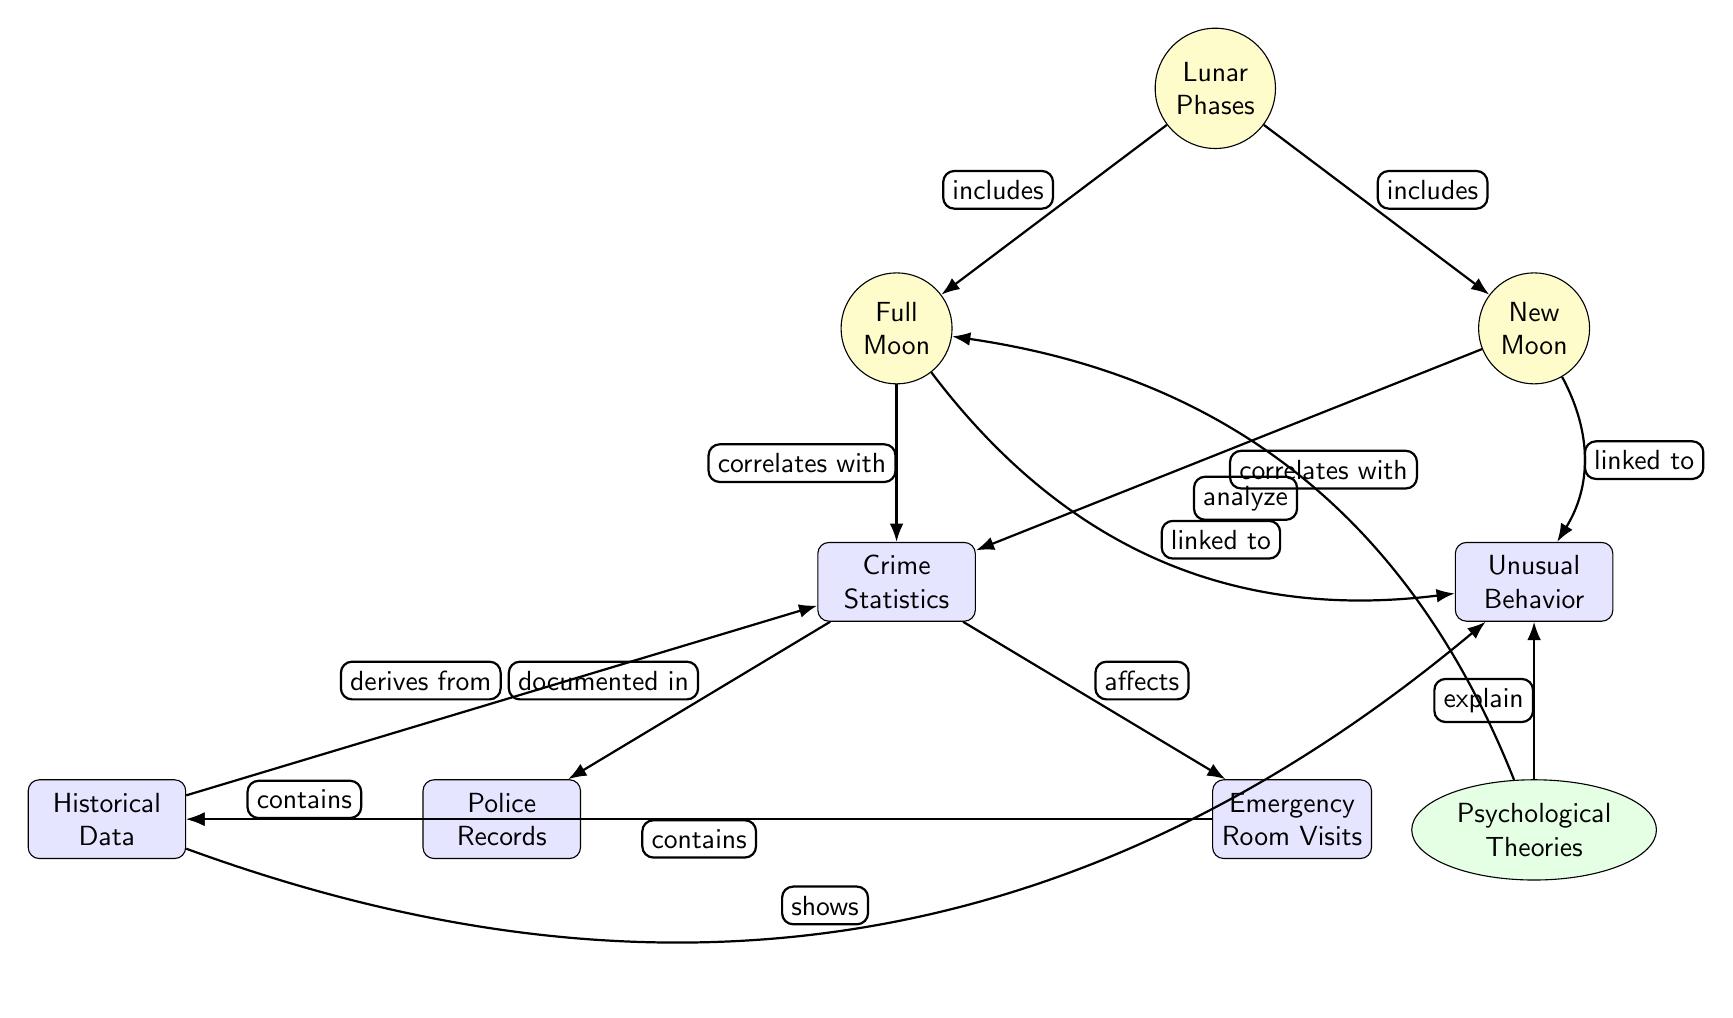What's the total number of lunar phases indicated in the diagram? The diagram includes two specific lunar phases: Full Moon and New Moon, which are both connected to the central node Lunar Phases. Counting these gives a total of 2 lunar phases.
Answer: 2 What type of theories explain unusual behavior? The diagram indicates "Psychological Theories" as the type of theories that explain unusual behavior, which is connected to the unusual behavior node.
Answer: Psychological Theories Which node correlates with crime statistics? Both Full Moon and New Moon nodes correlate with the Crime Statistics node, as indicated by the edges showing "correlates with" connecting these nodes.
Answer: Full Moon, New Moon How do emergency room visits relate to crime? The diagram indicates a relationship where Emergency Room Visits are affected by Crime Statistics, showing a direct connection from the crime node to the emergency room node labeled "affects".
Answer: Affects Are police records included in the historical data? Yes, the diagram shows police records as a component that contains historical data, as indicated by the edge from the Police Records node to the Historical Data node labeled "contains".
Answer: Yes What does the historical data node show? The Historical Data node shows Unusual Behavior, as indicated by the edge labeled "shows" connecting Historical Data to the Unusual Behavior node.
Answer: Unusual Behavior What links full moon phases to unusual behavior? The diagram shows a link between the Full Moon phase and unusual behavior, outlined by the edge labeled "linked to", implying a direct relationship.
Answer: Linked to What type of data is derived from crime statistics? Historical Data is derived from Crime Statistics, shown by the edge labeled "derives from", illustrating the flow of information in the diagram.
Answer: Historical Data 